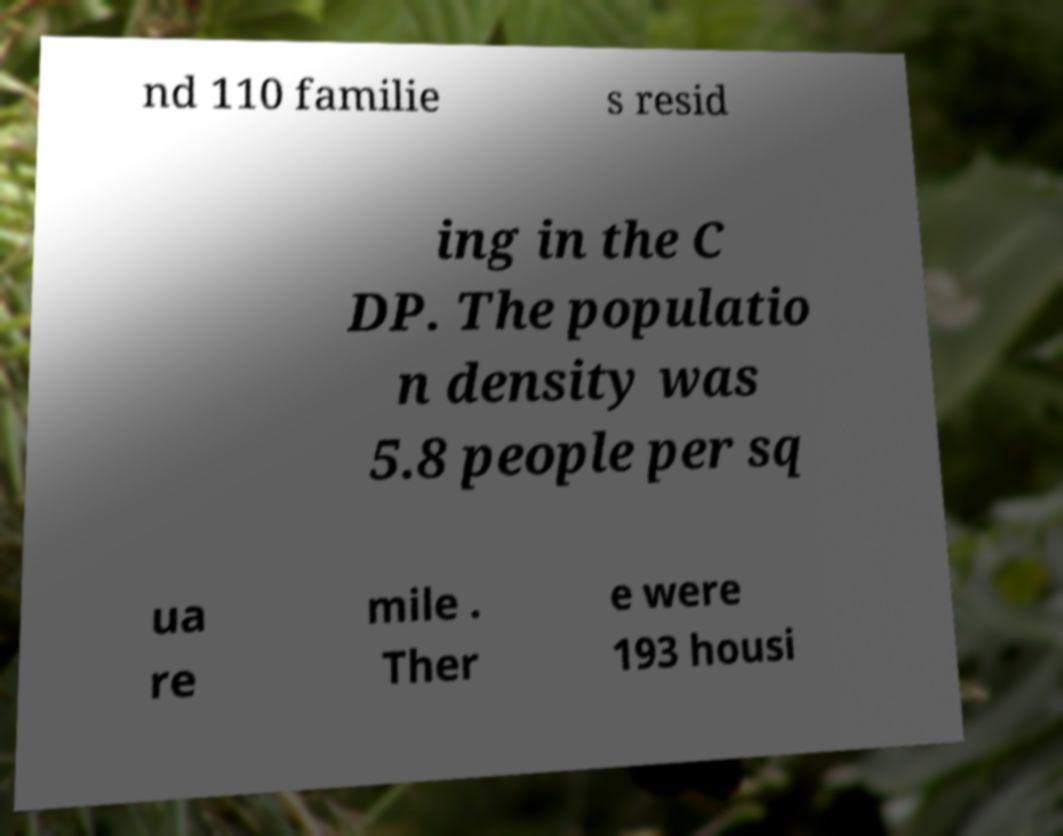I need the written content from this picture converted into text. Can you do that? nd 110 familie s resid ing in the C DP. The populatio n density was 5.8 people per sq ua re mile . Ther e were 193 housi 